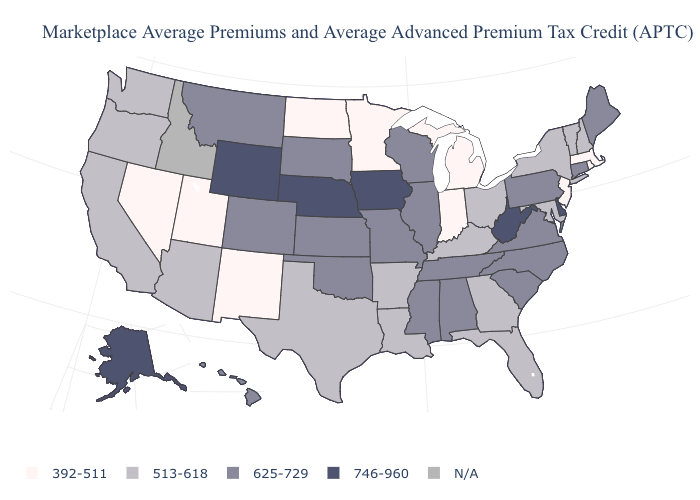What is the lowest value in the USA?
Answer briefly. 392-511. What is the value of Nevada?
Keep it brief. 392-511. Name the states that have a value in the range 625-729?
Answer briefly. Alabama, Colorado, Connecticut, Hawaii, Illinois, Kansas, Maine, Mississippi, Missouri, Montana, North Carolina, Oklahoma, Pennsylvania, South Carolina, South Dakota, Tennessee, Virginia, Wisconsin. What is the value of West Virginia?
Short answer required. 746-960. What is the lowest value in the USA?
Write a very short answer. 392-511. Name the states that have a value in the range 392-511?
Short answer required. Indiana, Massachusetts, Michigan, Minnesota, Nevada, New Jersey, New Mexico, North Dakota, Rhode Island, Utah. What is the highest value in the USA?
Write a very short answer. 746-960. Among the states that border Indiana , does Michigan have the lowest value?
Write a very short answer. Yes. Among the states that border Idaho , does Wyoming have the highest value?
Short answer required. Yes. What is the value of Indiana?
Give a very brief answer. 392-511. What is the value of Florida?
Quick response, please. 513-618. Name the states that have a value in the range 513-618?
Be succinct. Arizona, Arkansas, California, Florida, Georgia, Kentucky, Louisiana, Maryland, New Hampshire, New York, Ohio, Oregon, Texas, Vermont, Washington. Does the first symbol in the legend represent the smallest category?
Quick response, please. Yes. 